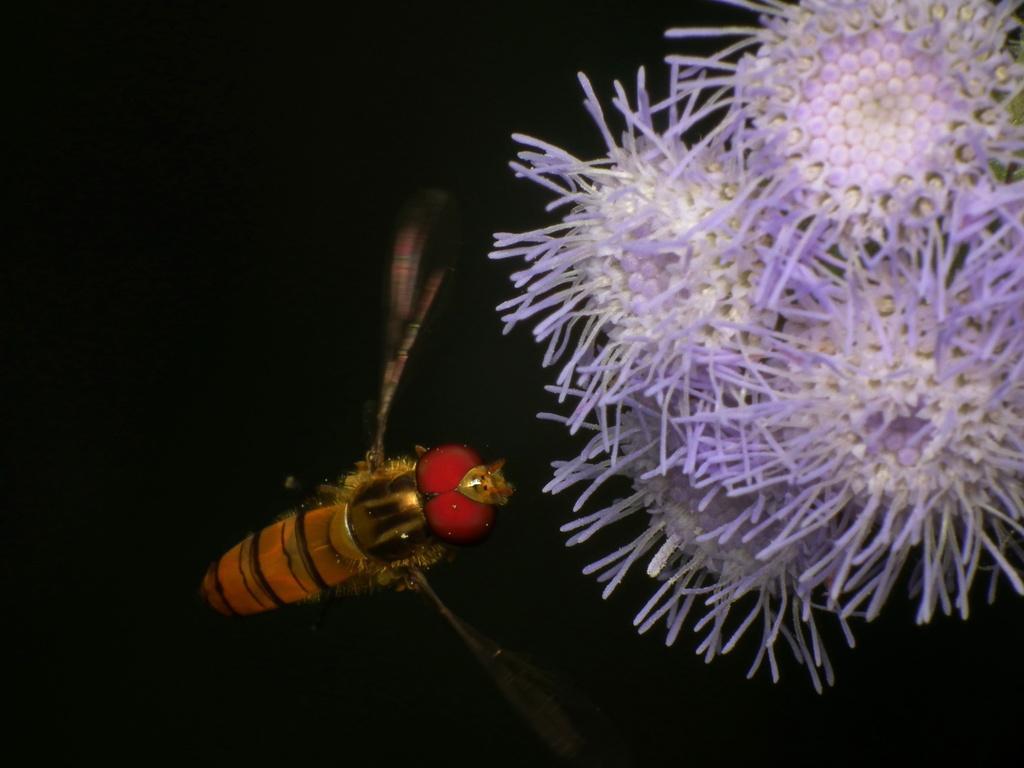What type of creature can be seen in the image? There is an insect in the image. What other living organisms are present in the image? There are flowers in the image. What is the color of the background in the image? The background of the image is dark. What type of invention is being demonstrated by the insect in the image? There is no invention being demonstrated by the insect in the image; it is simply an insect among flowers. Can you tell me how many elbows the insect has in the image? Insects do not have elbows, as they have exoskeletons and jointed legs instead of limbs with elbows. 